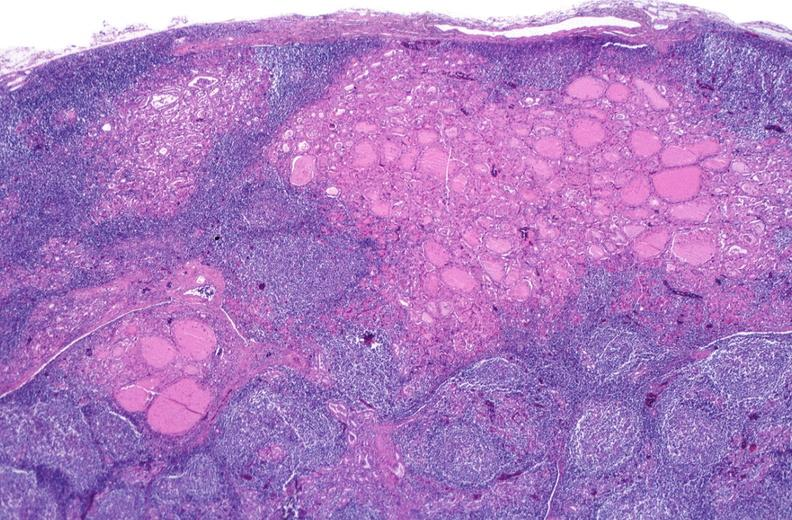s endocrine present?
Answer the question using a single word or phrase. Yes 